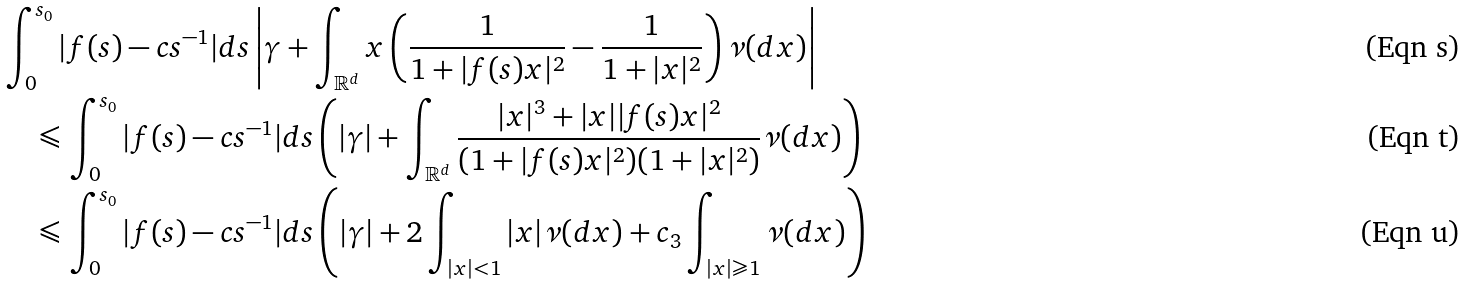Convert formula to latex. <formula><loc_0><loc_0><loc_500><loc_500>& \int _ { 0 } ^ { s _ { 0 } } | f ( s ) - c s ^ { - 1 } | d s \left | \gamma + \int _ { \mathbb { R } ^ { d } } x \left ( \frac { 1 } { 1 + | f ( s ) x | ^ { 2 } } - \frac { 1 } { 1 + | x | ^ { 2 } } \right ) \nu ( d x ) \right | \\ & \quad \leqslant \int _ { 0 } ^ { s _ { 0 } } | f ( s ) - c s ^ { - 1 } | d s \left ( | \gamma | + \int _ { \mathbb { R } ^ { d } } \frac { | x | ^ { 3 } + | x | | f ( s ) x | ^ { 2 } } { ( 1 + | f ( s ) x | ^ { 2 } ) ( 1 + | x | ^ { 2 } ) } \nu ( d x ) \right ) \\ & \quad \leqslant \int _ { 0 } ^ { s _ { 0 } } | f ( s ) - c s ^ { - 1 } | d s \left ( | \gamma | + 2 \int _ { | x | < 1 } | x | \nu ( d x ) + c _ { 3 } \int _ { | x | \geqslant 1 } \nu ( d x ) \right )</formula> 